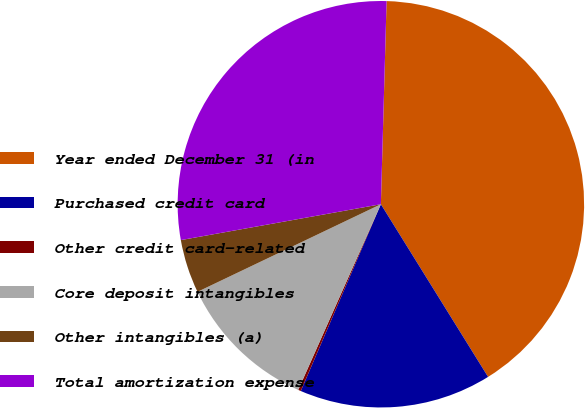<chart> <loc_0><loc_0><loc_500><loc_500><pie_chart><fcel>Year ended December 31 (in<fcel>Purchased credit card<fcel>Other credit card-related<fcel>Core deposit intangibles<fcel>Other intangibles (a)<fcel>Total amortization expense<nl><fcel>40.71%<fcel>15.29%<fcel>0.22%<fcel>11.24%<fcel>4.27%<fcel>28.27%<nl></chart> 